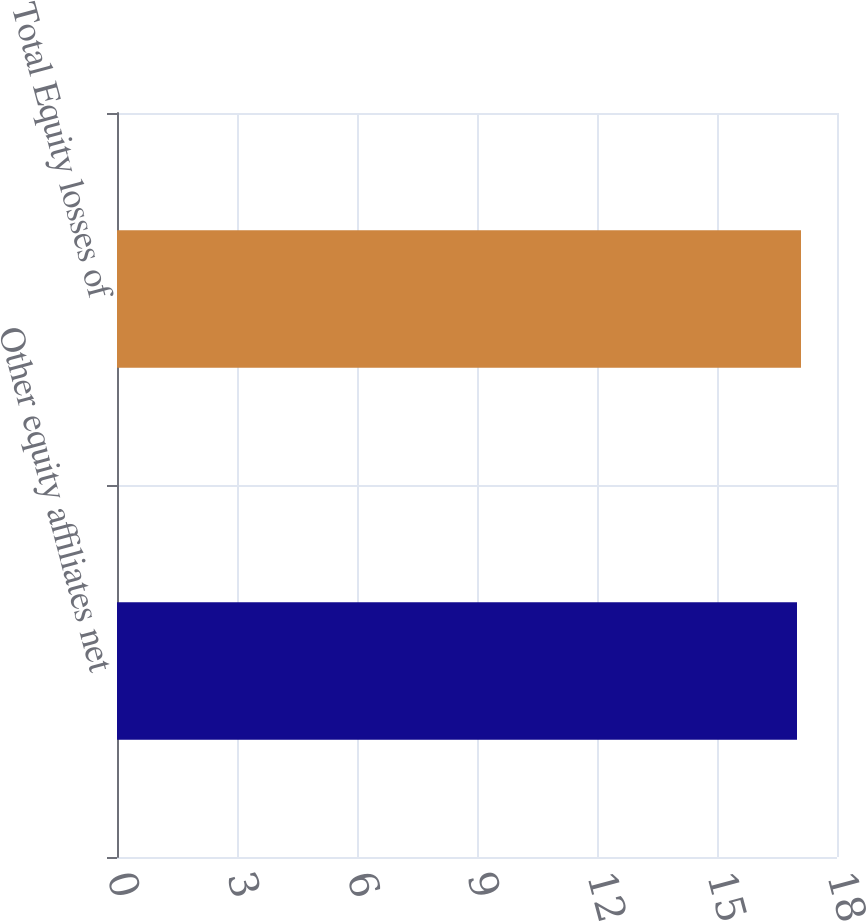Convert chart to OTSL. <chart><loc_0><loc_0><loc_500><loc_500><bar_chart><fcel>Other equity affiliates net<fcel>Total Equity losses of<nl><fcel>17<fcel>17.1<nl></chart> 